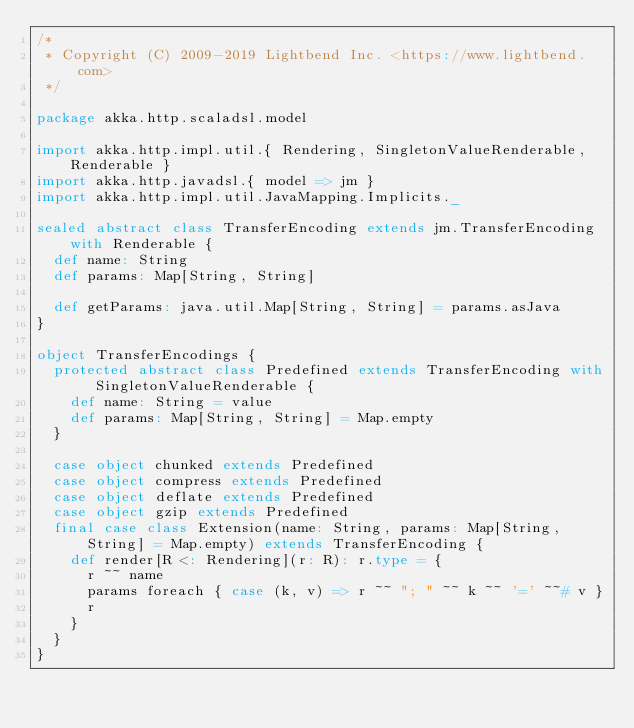Convert code to text. <code><loc_0><loc_0><loc_500><loc_500><_Scala_>/*
 * Copyright (C) 2009-2019 Lightbend Inc. <https://www.lightbend.com>
 */

package akka.http.scaladsl.model

import akka.http.impl.util.{ Rendering, SingletonValueRenderable, Renderable }
import akka.http.javadsl.{ model => jm }
import akka.http.impl.util.JavaMapping.Implicits._

sealed abstract class TransferEncoding extends jm.TransferEncoding with Renderable {
  def name: String
  def params: Map[String, String]

  def getParams: java.util.Map[String, String] = params.asJava
}

object TransferEncodings {
  protected abstract class Predefined extends TransferEncoding with SingletonValueRenderable {
    def name: String = value
    def params: Map[String, String] = Map.empty
  }

  case object chunked extends Predefined
  case object compress extends Predefined
  case object deflate extends Predefined
  case object gzip extends Predefined
  final case class Extension(name: String, params: Map[String, String] = Map.empty) extends TransferEncoding {
    def render[R <: Rendering](r: R): r.type = {
      r ~~ name
      params foreach { case (k, v) => r ~~ "; " ~~ k ~~ '=' ~~# v }
      r
    }
  }
}
</code> 